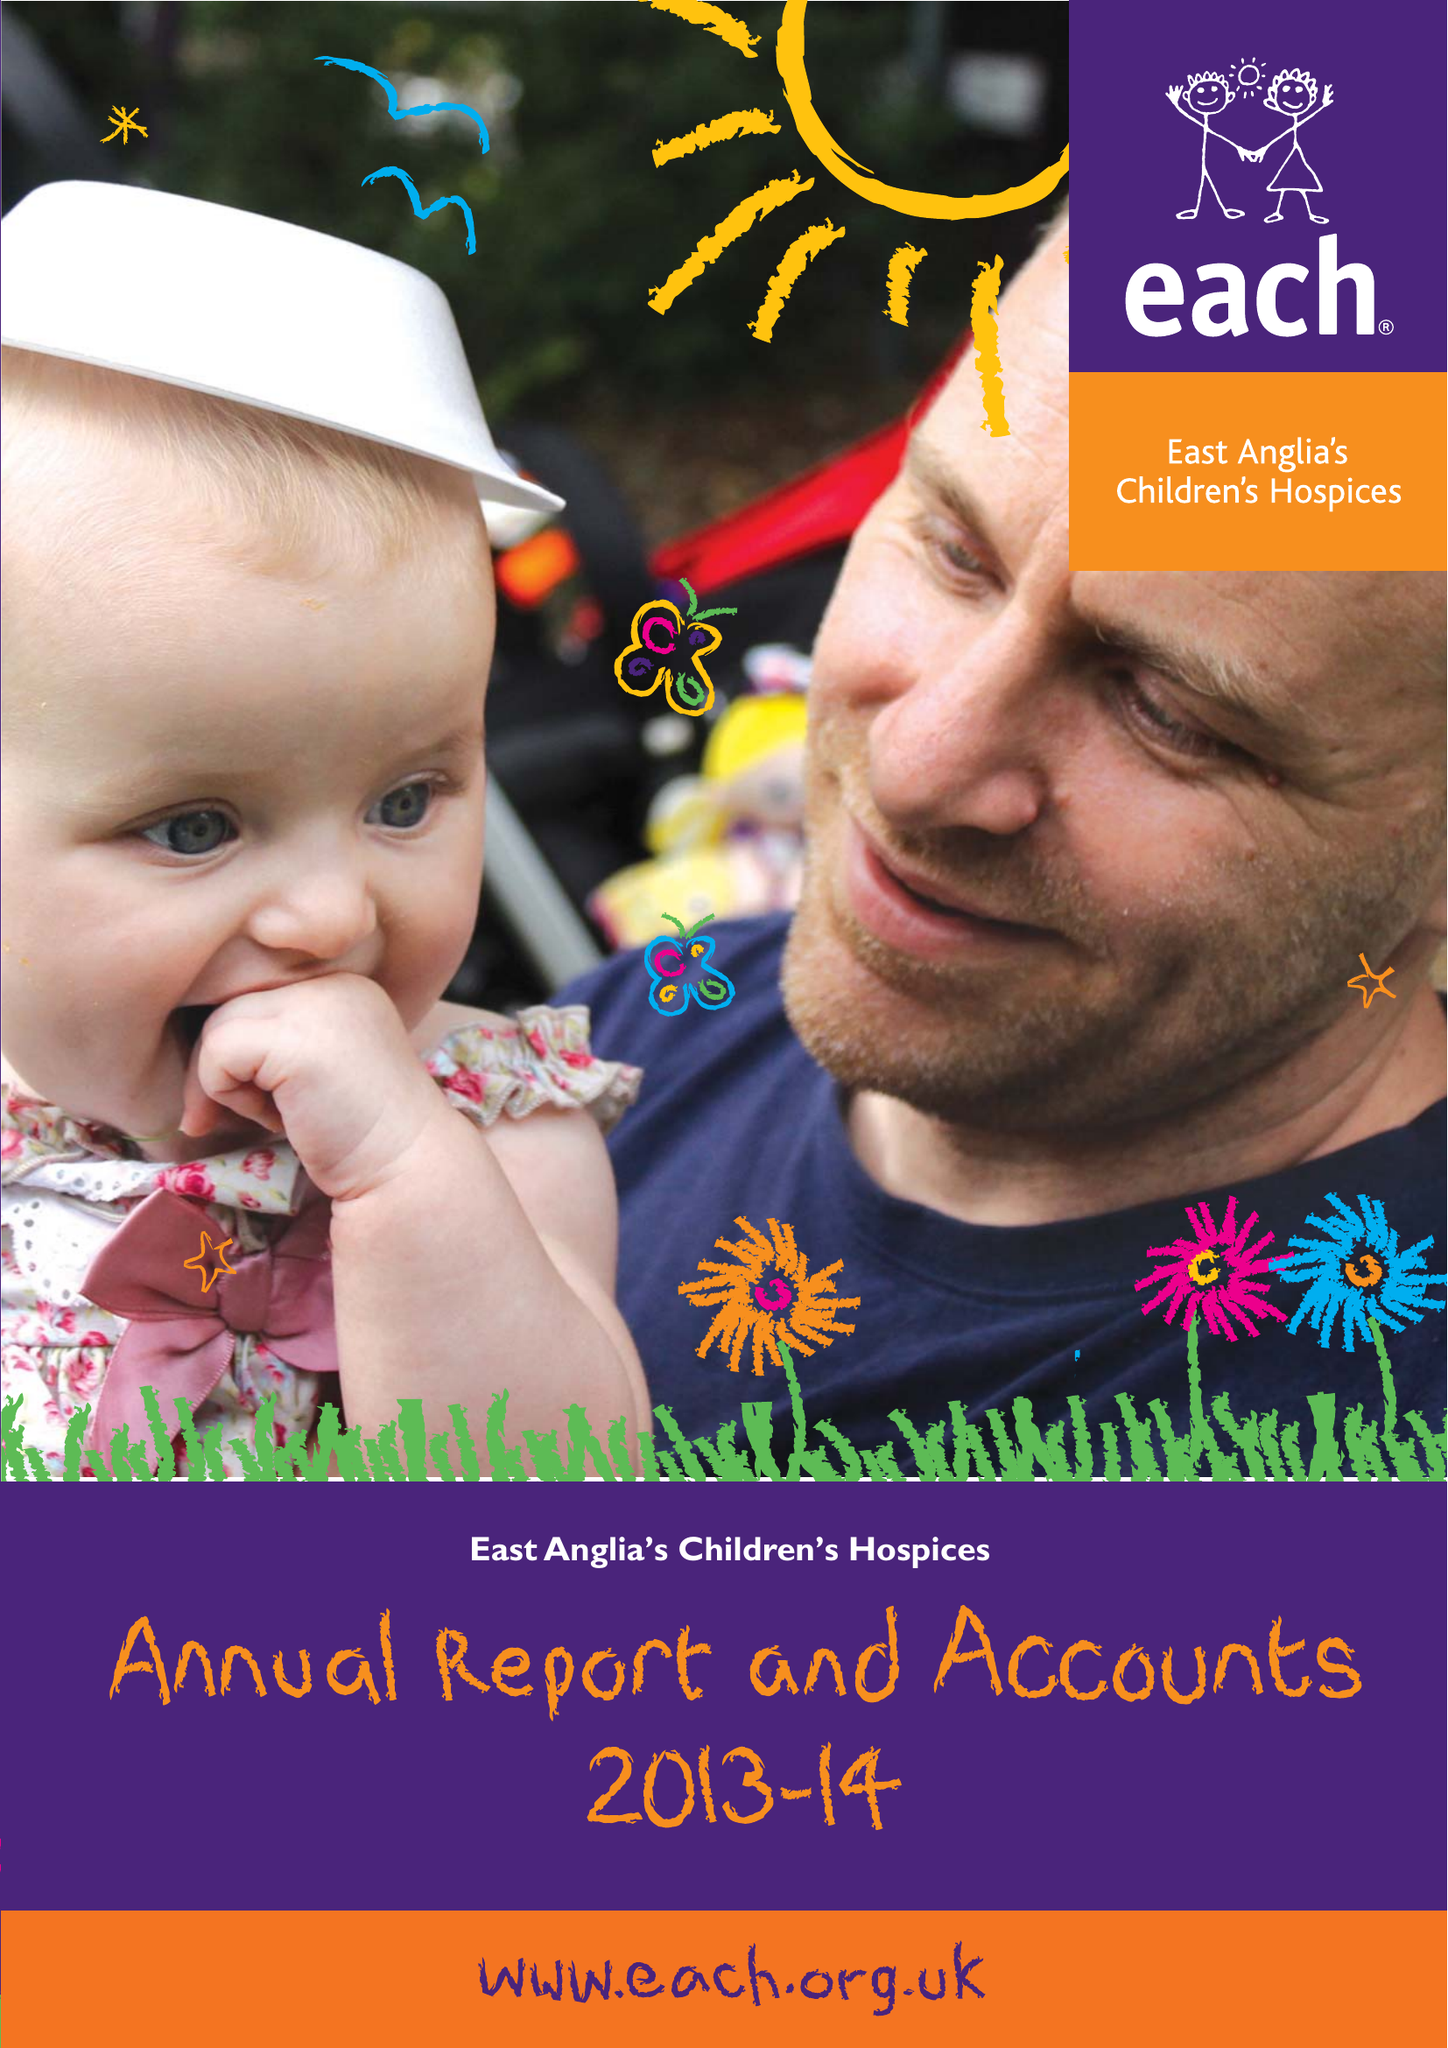What is the value for the address__postcode?
Answer the question using a single word or phrase. CB24 6DF 